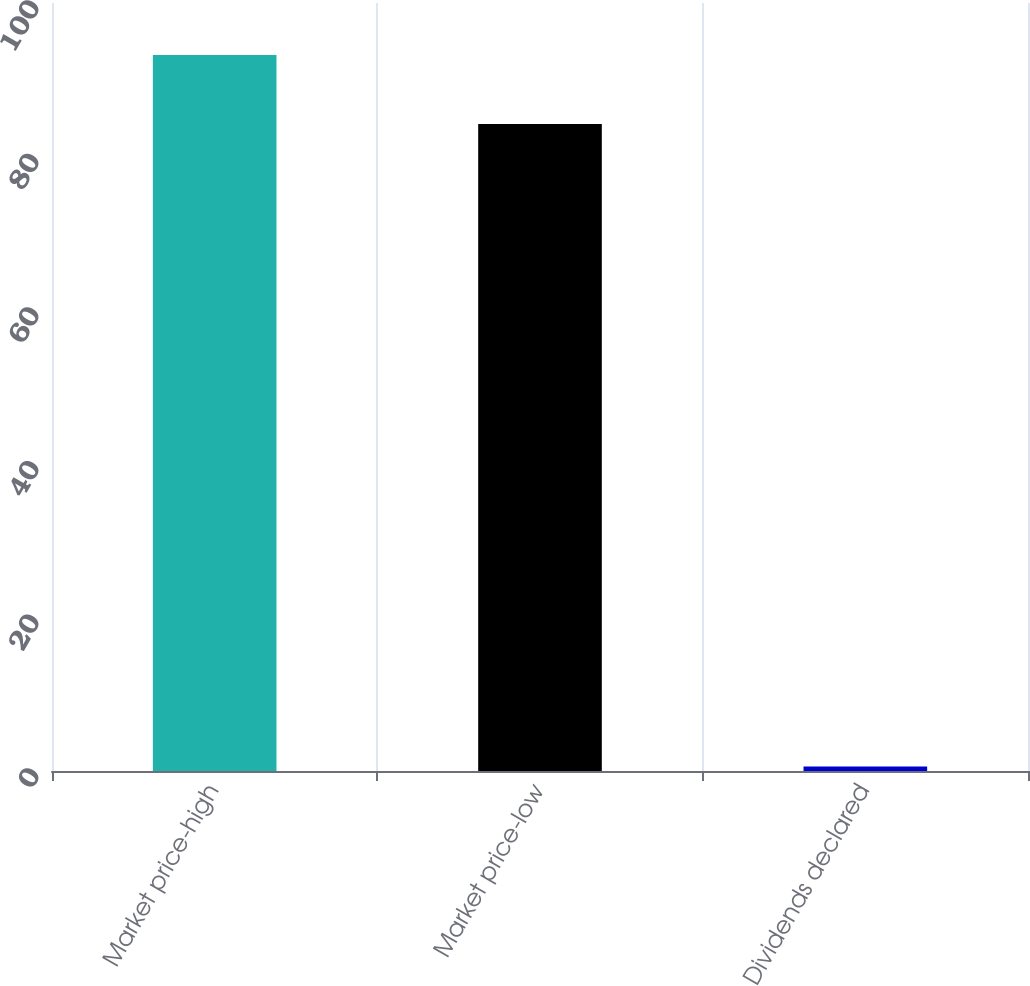<chart> <loc_0><loc_0><loc_500><loc_500><bar_chart><fcel>Market price-high<fcel>Market price-low<fcel>Dividends declared<nl><fcel>93.24<fcel>84.25<fcel>0.6<nl></chart> 